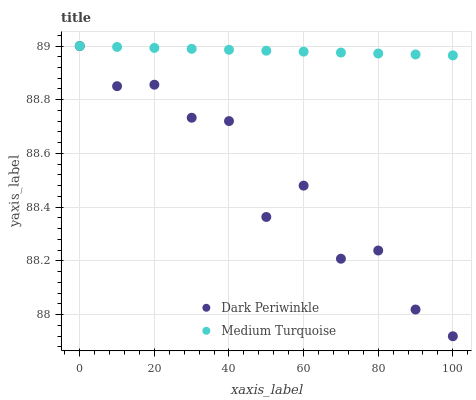Does Dark Periwinkle have the minimum area under the curve?
Answer yes or no. Yes. Does Medium Turquoise have the maximum area under the curve?
Answer yes or no. Yes. Does Medium Turquoise have the minimum area under the curve?
Answer yes or no. No. Is Medium Turquoise the smoothest?
Answer yes or no. Yes. Is Dark Periwinkle the roughest?
Answer yes or no. Yes. Is Medium Turquoise the roughest?
Answer yes or no. No. Does Dark Periwinkle have the lowest value?
Answer yes or no. Yes. Does Medium Turquoise have the lowest value?
Answer yes or no. No. Does Medium Turquoise have the highest value?
Answer yes or no. Yes. Does Dark Periwinkle intersect Medium Turquoise?
Answer yes or no. Yes. Is Dark Periwinkle less than Medium Turquoise?
Answer yes or no. No. Is Dark Periwinkle greater than Medium Turquoise?
Answer yes or no. No. 